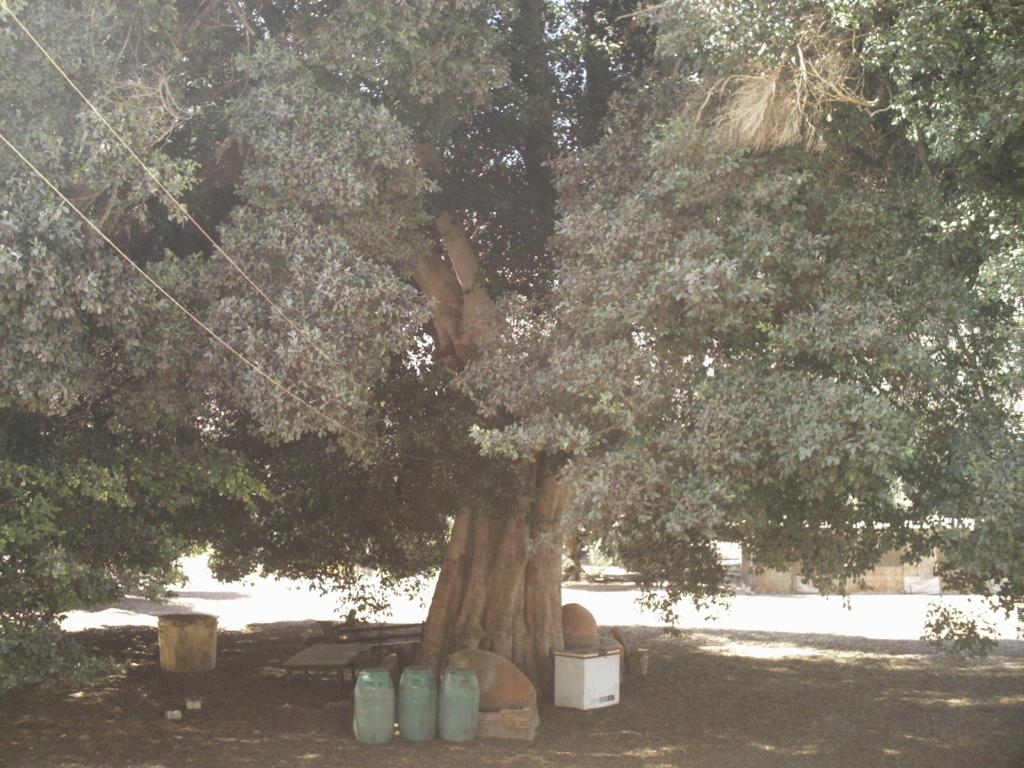What type of plant can be seen in the image? There is a tree in the image. Where is the tree located? The tree is on the ground. What objects are in front of the tree? There are boxes, barrels, and benches in front of the tree. What structure is located behind the tree? There is a house behind the tree. What type of fog can be seen around the tree in the image? There is no fog present in the image; it is a clear day. Is there a ship visible in the image? No, there is no ship present in the image. 